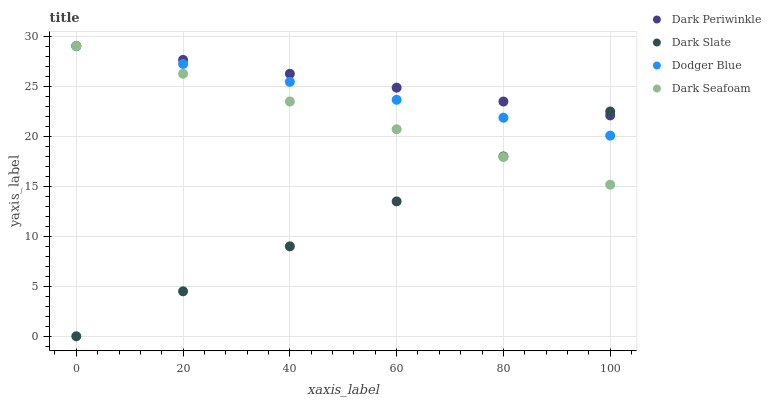Does Dark Slate have the minimum area under the curve?
Answer yes or no. Yes. Does Dark Periwinkle have the maximum area under the curve?
Answer yes or no. Yes. Does Dark Seafoam have the minimum area under the curve?
Answer yes or no. No. Does Dark Seafoam have the maximum area under the curve?
Answer yes or no. No. Is Dark Slate the smoothest?
Answer yes or no. Yes. Is Dark Periwinkle the roughest?
Answer yes or no. Yes. Is Dark Seafoam the smoothest?
Answer yes or no. No. Is Dark Seafoam the roughest?
Answer yes or no. No. Does Dark Slate have the lowest value?
Answer yes or no. Yes. Does Dark Seafoam have the lowest value?
Answer yes or no. No. Does Dark Periwinkle have the highest value?
Answer yes or no. Yes. Does Dark Seafoam intersect Dodger Blue?
Answer yes or no. Yes. Is Dark Seafoam less than Dodger Blue?
Answer yes or no. No. Is Dark Seafoam greater than Dodger Blue?
Answer yes or no. No. 